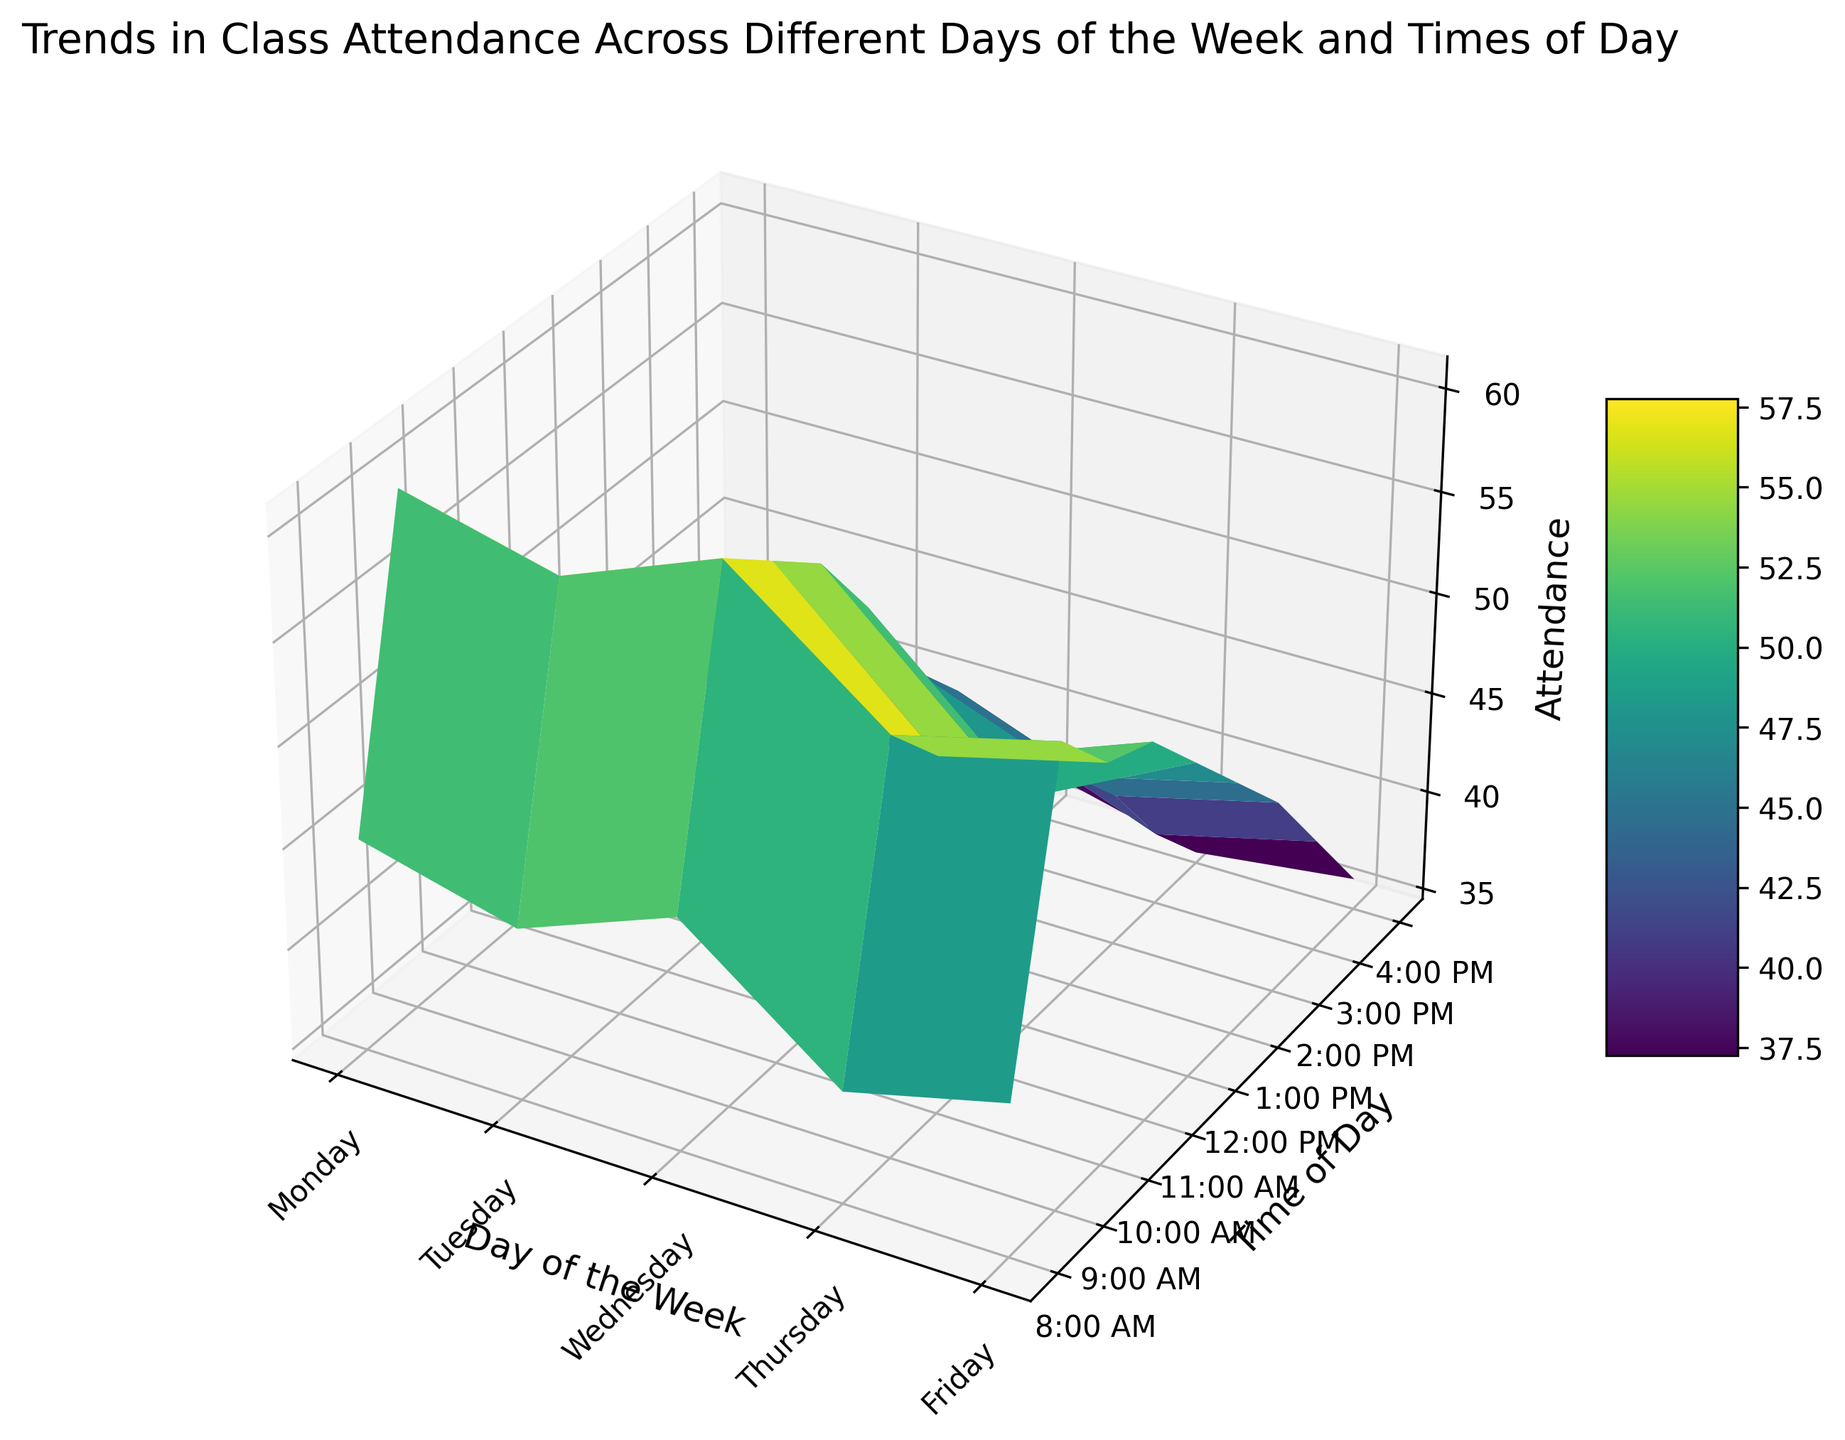What is the highest attendance observed, and on which day and time does it occur? The highest attendance can be identified as the peak of the surface on the 3D plot. Looking at the chart, the highest point is on Wednesday at 9:00 AM.
Answer: 61 on Wednesday at 9:00 AM Which day has the lowest average attendance? To find this, calculate the average attendance for each day and compare. The day with the lowest average attendance is Thursday.
Answer: Thursday What is the average attendance on Monday between 8:00 AM and 12:00 PM? Sum the attendance values from 8:00 AM to 12:00 PM on Monday (45 + 60 + 55 + 52 + 50) and divide by the number of time slots (5). The average is (45 + 60 + 55 + 52 + 50) / 5 = 52.4.
Answer: 52.4 Which time slot has the most consistent attendance across all days? For each time slot, calculate the variance of attendance across all days. The time slot with the lowest variance is 2:00 PM, indicating the most consistent attendance.
Answer: 2:00 PM Compare the trend in attendance from 8:00 AM to 4:00 PM on Monday versus Friday. Which day shows a more significant decrease in attendance? Calculate the difference in attendance from 8:00 AM to 4:00 PM for both days. On Monday, the decrease is (45 - 40 = 5), and on Friday, it's (42 - 36 = 6). Thus, Friday shows a more significant decrease in attendance.
Answer: Friday Is there a time slot that consistently shows lower attendance throughout the week? Identify the time slot with the lowest attendance values consistently from Monday to Friday. The 4:00 PM slot consistently shows the lowest attendance levels.
Answer: 4:00 PM On average, does attendance increase or decrease after lunch (12:00 PM) on any given day? Calculate the average attendance for before and after 12:00 PM and compare. For most days, the average attendance decreases after 12:00 PM.
Answer: Decrease What is the overall trend in attendance from Monday to Friday at 10:00 AM? Observe the attendance values at 10:00 AM from Monday to Friday (55, 53, 59, 52, 54). The trend fluctuates but stays relatively stable around the 50s.
Answer: Stable Which day shows the least variation in attendance across all time slots? Calculate the variance in attendance for each day and compare. The day with the least variation should have the lowest variance, which is Monday.
Answer: Monday 